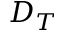<formula> <loc_0><loc_0><loc_500><loc_500>D _ { T }</formula> 